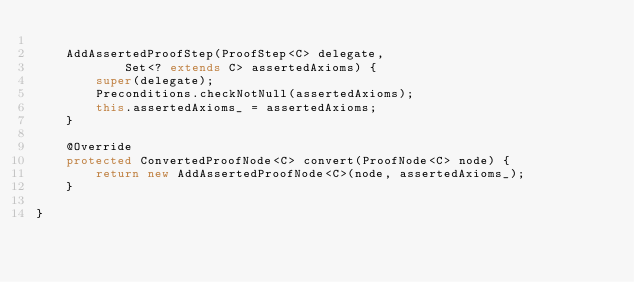<code> <loc_0><loc_0><loc_500><loc_500><_Java_>
	AddAssertedProofStep(ProofStep<C> delegate,
			Set<? extends C> assertedAxioms) {
		super(delegate);
		Preconditions.checkNotNull(assertedAxioms);
		this.assertedAxioms_ = assertedAxioms;
	}

	@Override
	protected ConvertedProofNode<C> convert(ProofNode<C> node) {
		return new AddAssertedProofNode<C>(node, assertedAxioms_);
	}

}
</code> 